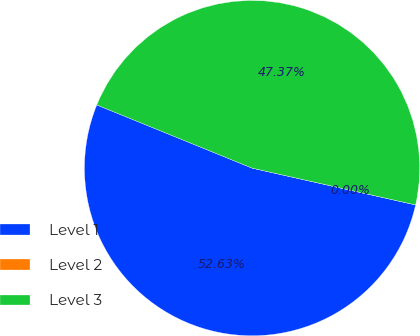Convert chart. <chart><loc_0><loc_0><loc_500><loc_500><pie_chart><fcel>Level 1<fcel>Level 2<fcel>Level 3<nl><fcel>52.62%<fcel>0.0%<fcel>47.37%<nl></chart> 